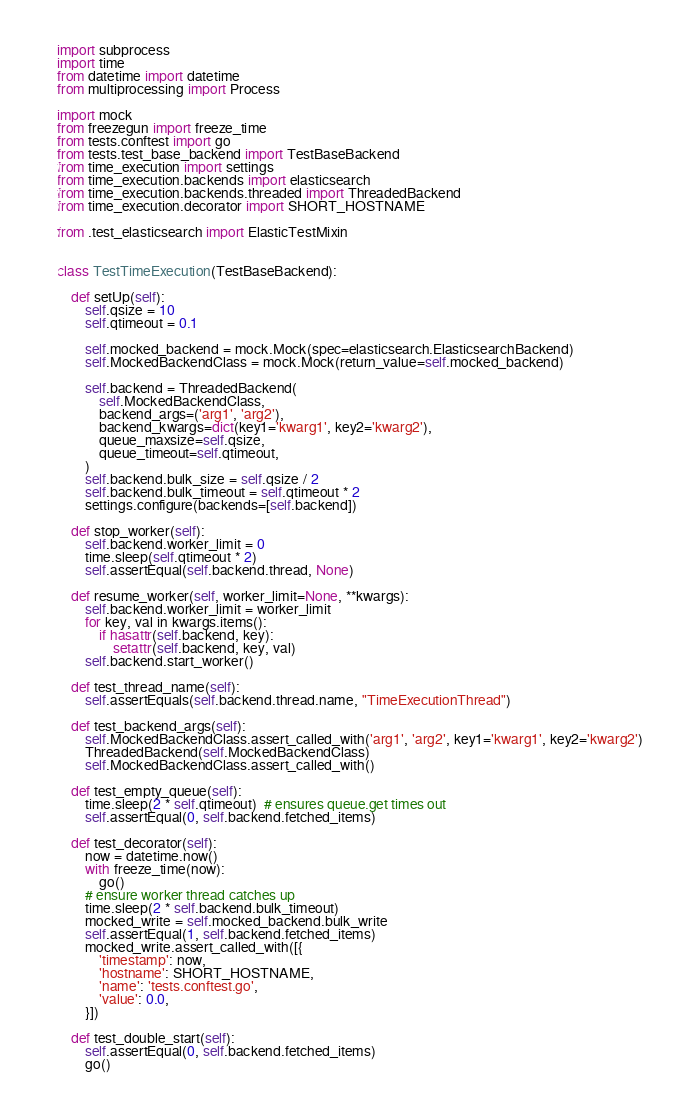<code> <loc_0><loc_0><loc_500><loc_500><_Python_>
import subprocess
import time
from datetime import datetime
from multiprocessing import Process

import mock
from freezegun import freeze_time
from tests.conftest import go
from tests.test_base_backend import TestBaseBackend
from time_execution import settings
from time_execution.backends import elasticsearch
from time_execution.backends.threaded import ThreadedBackend
from time_execution.decorator import SHORT_HOSTNAME

from .test_elasticsearch import ElasticTestMixin


class TestTimeExecution(TestBaseBackend):

    def setUp(self):
        self.qsize = 10
        self.qtimeout = 0.1

        self.mocked_backend = mock.Mock(spec=elasticsearch.ElasticsearchBackend)
        self.MockedBackendClass = mock.Mock(return_value=self.mocked_backend)

        self.backend = ThreadedBackend(
            self.MockedBackendClass,
            backend_args=('arg1', 'arg2'),
            backend_kwargs=dict(key1='kwarg1', key2='kwarg2'),
            queue_maxsize=self.qsize,
            queue_timeout=self.qtimeout,
        )
        self.backend.bulk_size = self.qsize / 2
        self.backend.bulk_timeout = self.qtimeout * 2
        settings.configure(backends=[self.backend])

    def stop_worker(self):
        self.backend.worker_limit = 0
        time.sleep(self.qtimeout * 2)
        self.assertEqual(self.backend.thread, None)

    def resume_worker(self, worker_limit=None, **kwargs):
        self.backend.worker_limit = worker_limit
        for key, val in kwargs.items():
            if hasattr(self.backend, key):
                setattr(self.backend, key, val)
        self.backend.start_worker()

    def test_thread_name(self):
        self.assertEquals(self.backend.thread.name, "TimeExecutionThread")

    def test_backend_args(self):
        self.MockedBackendClass.assert_called_with('arg1', 'arg2', key1='kwarg1', key2='kwarg2')
        ThreadedBackend(self.MockedBackendClass)
        self.MockedBackendClass.assert_called_with()

    def test_empty_queue(self):
        time.sleep(2 * self.qtimeout)  # ensures queue.get times out
        self.assertEqual(0, self.backend.fetched_items)

    def test_decorator(self):
        now = datetime.now()
        with freeze_time(now):
            go()
        # ensure worker thread catches up
        time.sleep(2 * self.backend.bulk_timeout)
        mocked_write = self.mocked_backend.bulk_write
        self.assertEqual(1, self.backend.fetched_items)
        mocked_write.assert_called_with([{
            'timestamp': now,
            'hostname': SHORT_HOSTNAME,
            'name': 'tests.conftest.go',
            'value': 0.0,
        }])

    def test_double_start(self):
        self.assertEqual(0, self.backend.fetched_items)
        go()</code> 